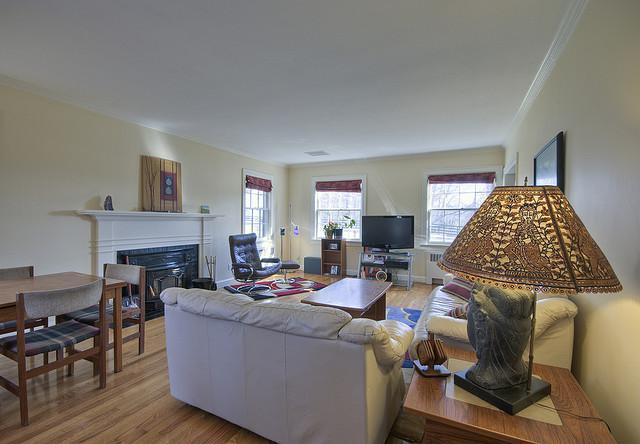What color are the sofa seats surrounding the table on the rug?
Answer the question by selecting the correct answer among the 4 following choices and explain your choice with a short sentence. The answer should be formatted with the following format: `Answer: choice
Rationale: rationale.`
Options: Red, green, blue, cream. Answer: cream.
Rationale: The sofas in the living room are made of light cream colored leather. 